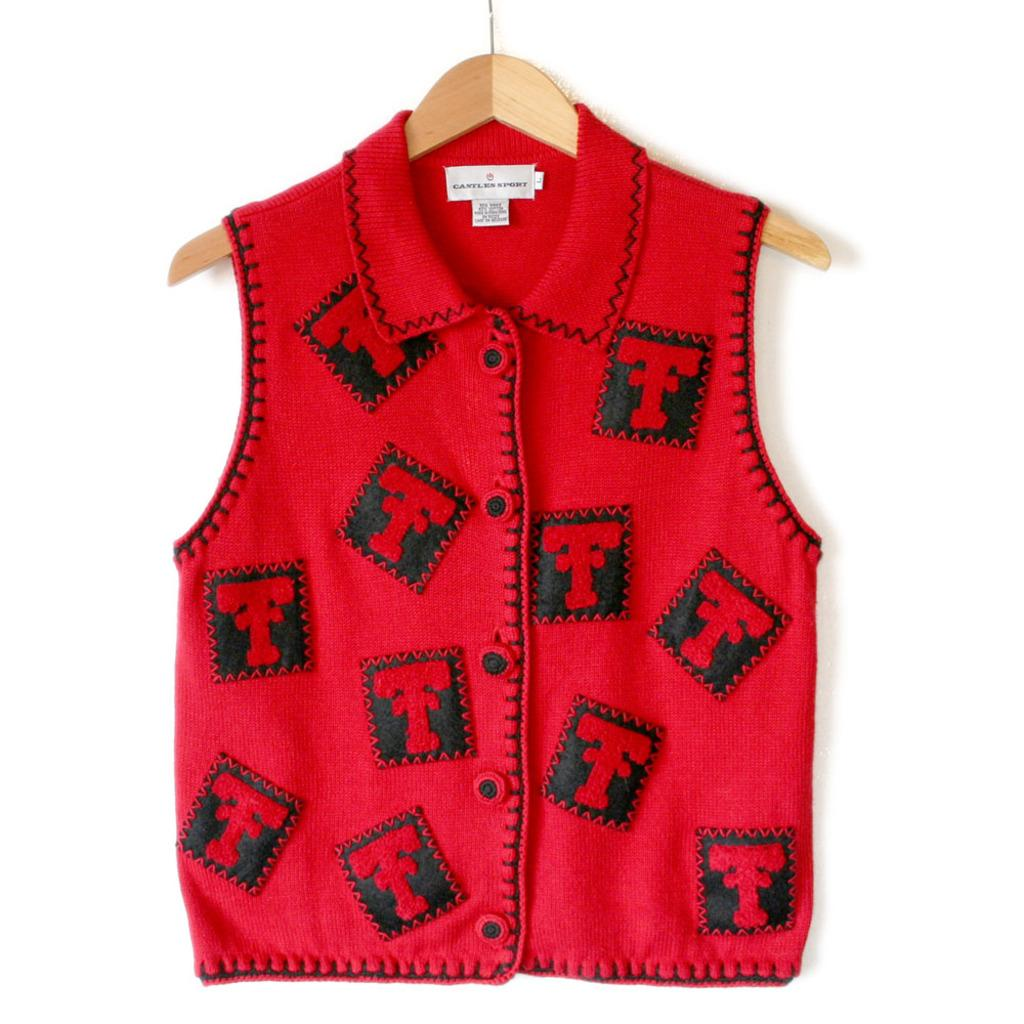What is hanging on the hanger in the image? There is a shirt on a hanger in the image. What color is the background of the image? The background of the image is white. Where is the cannon located in the image? There is no cannon present in the image. How many rings are visible on the shirt in the image? There is no information about rings on the shirt in the image. 